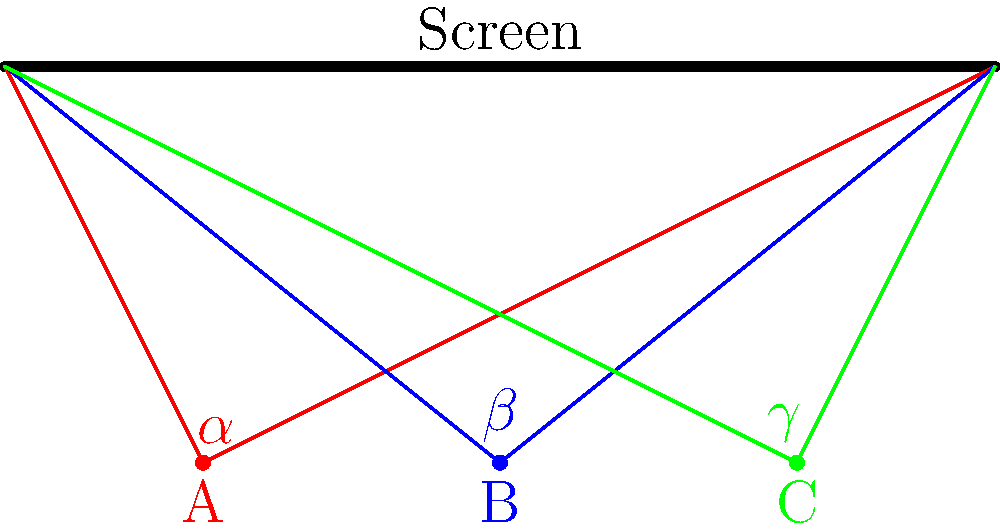In a retro cinema reminiscent of the 80s, three movie buffs are seated at different positions (A, B, and C) as shown in the diagram. The viewing angles ($\alpha$, $\beta$, and $\gamma$) represent how much of the screen each viewer can see. If $\alpha = 120°$ and $\gamma = 60°$, what is the measure of angle $\beta$? Let's approach this step-by-step, channeling our inner film geek:

1) First, observe that the three viewers form a line parallel to the screen, creating similar triangles.

2) In similar triangles, the ratio of corresponding angles remains constant. This means that the viewing angles are inversely proportional to the distance from the center of the screen.

3) Viewer A (red) has the widest angle ($\alpha = 120°$), while viewer C (green) has the narrowest ($\gamma = 60°$).

4) Viewer B (blue) is exactly in the middle, so their viewing angle $\beta$ should be the average of $\alpha$ and $\gamma$.

5) To calculate the average:
   $$\beta = \frac{\alpha + \gamma}{2} = \frac{120° + 60°}{2} = \frac{180°}{2} = 90°$$

6) This result makes sense cinematically: the central seat (B) provides a perfectly perpendicular view of the screen, reminiscent of the ideal viewing experience in classic 80s movie theaters.

Therefore, the measure of angle $\beta$ is 90°.
Answer: 90° 